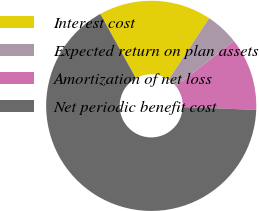<chart> <loc_0><loc_0><loc_500><loc_500><pie_chart><fcel>Interest cost<fcel>Expected return on plan assets<fcel>Amortization of net loss<fcel>Net periodic benefit cost<nl><fcel>17.35%<fcel>5.1%<fcel>11.22%<fcel>66.33%<nl></chart> 